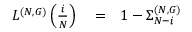<formula> <loc_0><loc_0><loc_500><loc_500>\begin{array} { r l r } { L ^ { ( N , G ) } \left ( \frac { i } { N } \right ) } & = } & { 1 - \Sigma _ { N - i } ^ { ( N , G ) } } \end{array}</formula> 